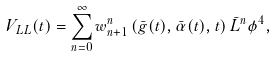<formula> <loc_0><loc_0><loc_500><loc_500>V _ { L L } ( t ) = \sum ^ { \infty } _ { n = 0 } w ^ { n } _ { n + 1 } \left ( \bar { g } ( t ) , \bar { \alpha } ( t ) , t \right ) \bar { L } ^ { n } \phi ^ { 4 } ,</formula> 